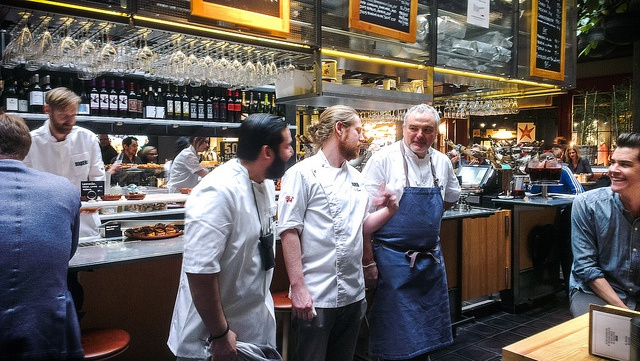Describe the objects in this image and their specific colors. I can see people in black, lavender, gray, and darkgray tones, people in black, navy, lavender, and darkblue tones, people in black, white, and darkgray tones, people in black, navy, gray, and darkgray tones, and wine glass in black, darkgray, gray, and lightgray tones in this image. 